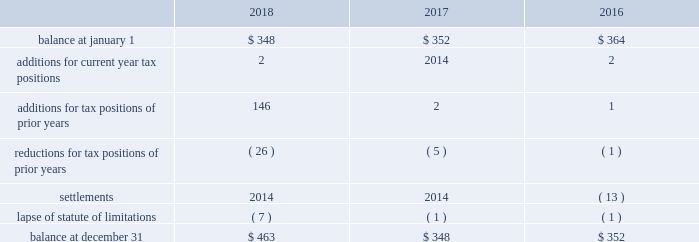The aes corporation notes to consolidated financial statements 2014 ( continued ) december 31 , 2018 , 2017 , and 2016 the following is a reconciliation of the beginning and ending amounts of unrecognized tax benefits for the periods indicated ( in millions ) : .
The company and certain of its subsidiaries are currently under examination by the relevant taxing authorities for various tax years .
The company regularly assesses the potential outcome of these examinations in each of the taxing jurisdictions when determining the adequacy of the amount of unrecognized tax benefit recorded .
While it is often difficult to predict the final outcome or the timing of resolution of any particular uncertain tax position , we believe we have appropriately accrued for our uncertain tax benefits .
However , audit outcomes and the timing of audit settlements and future events that would impact our previously recorded unrecognized tax benefits and the range of anticipated increases or decreases in unrecognized tax benefits are subject to significant uncertainty .
It is possible that the ultimate outcome of current or future examinations may exceed our provision for current unrecognized tax benefits in amounts that could be material , but cannot be estimated as of december 31 , 2018 .
Our effective tax rate and net income in any given future period could therefore be materially impacted .
22 .
Discontinued operations due to a portfolio evaluation in the first half of 2016 , management decided to pursue a strategic shift of its distribution companies in brazil , sul and eletropaulo , to reduce the company's exposure to the brazilian distribution market .
The disposals of sul and eletropaulo were completed in october 2016 and june 2018 , respectively .
Eletropaulo 2014 in november 2017 , eletropaulo converted its preferred shares into ordinary shares and transitioned the listing of those shares to the novo mercado , which is a listing segment of the brazilian stock exchange with the highest standards of corporate governance .
Upon conversion of the preferred shares into ordinary shares , aes no longer controlled eletropaulo , but maintained significant influence over the business .
As a result , the company deconsolidated eletropaulo .
After deconsolidation , the company's 17% ( 17 % ) ownership interest was reflected as an equity method investment .
The company recorded an after-tax loss on deconsolidation of $ 611 million , which primarily consisted of $ 455 million related to cumulative translation losses and $ 243 million related to pension losses reclassified from aocl .
In december 2017 , all the remaining criteria were met for eletropaulo to qualify as a discontinued operation .
Therefore , its results of operations and financial position were reported as such in the consolidated financial statements for all periods presented .
In june 2018 , the company completed the sale of its entire 17% ( 17 % ) ownership interest in eletropaulo through a bidding process hosted by the brazilian securities regulator , cvm .
Gross proceeds of $ 340 million were received at our subsidiary in brazil , subject to the payment of taxes .
Upon disposal of eletropaulo , the company recorded a pre-tax gain on sale of $ 243 million ( after-tax $ 199 million ) .
Excluding the gain on sale , eletropaulo's pre-tax loss attributable to aes was immaterial for the year ended december 31 , 2018 .
Eletropaulo's pre-tax loss attributable to aes , including the loss on deconsolidation , for the years ended december 31 , 2017 and 2016 was $ 633 million and $ 192 million , respectively .
Prior to its classification as discontinued operations , eletropaulo was reported in the south america sbu reportable segment .
Sul 2014 the company executed an agreement for the sale of sul , a wholly-owned subsidiary , in june 2016 .
The results of operations and financial position of sul are reported as discontinued operations in the consolidated financial statements for all periods presented .
Upon meeting the held-for-sale criteria , the company recognized an after-tax loss of $ 382 million comprised of a pre-tax impairment charge of $ 783 million , offset by a tax benefit of $ 266 million related to the impairment of the sul long lived assets and a tax benefit of $ 135 million for deferred taxes related to the investment in sul .
Prior to the impairment charge , the carrying value of the sul asset group of $ 1.6 billion was greater than its approximate fair value less costs to sell .
However , the impairment charge was limited to the carrying value of the long lived assets of the sul disposal group. .
What was the percentage change of unrecognized tax benefits at year end between 2016 and 2017? 
Computations: ((348 - 352) / 352)
Answer: -0.01136. 